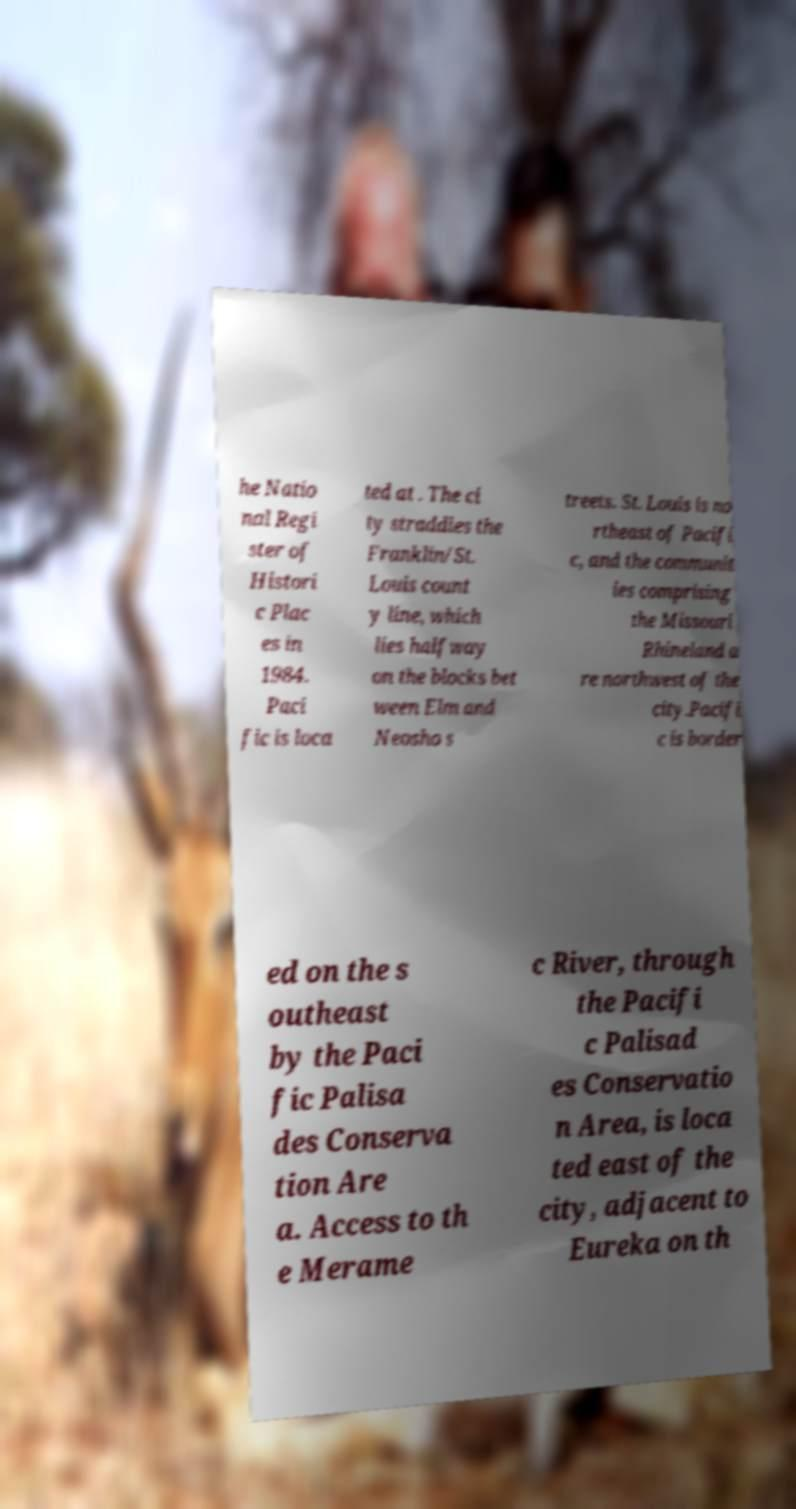Could you extract and type out the text from this image? he Natio nal Regi ster of Histori c Plac es in 1984. Paci fic is loca ted at . The ci ty straddles the Franklin/St. Louis count y line, which lies halfway on the blocks bet ween Elm and Neosho s treets. St. Louis is no rtheast of Pacifi c, and the communit ies comprising the Missouri Rhineland a re northwest of the city.Pacifi c is border ed on the s outheast by the Paci fic Palisa des Conserva tion Are a. Access to th e Merame c River, through the Pacifi c Palisad es Conservatio n Area, is loca ted east of the city, adjacent to Eureka on th 